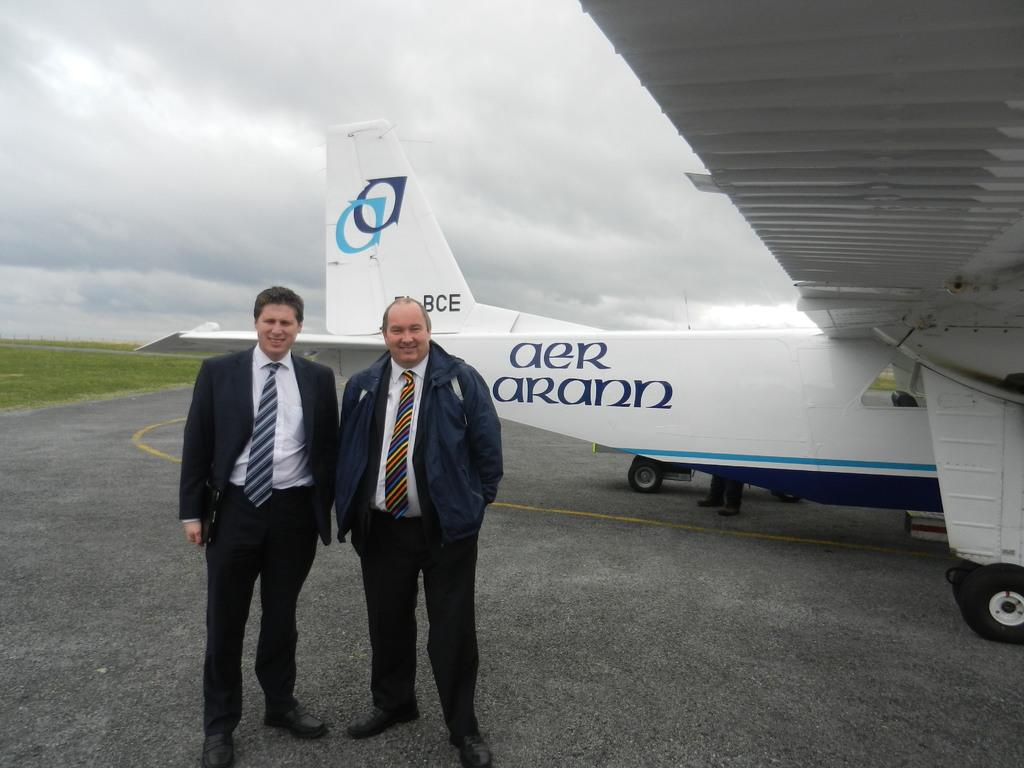Provide a one-sentence caption for the provided image. two men stand in front of an Aer Arann plane. 